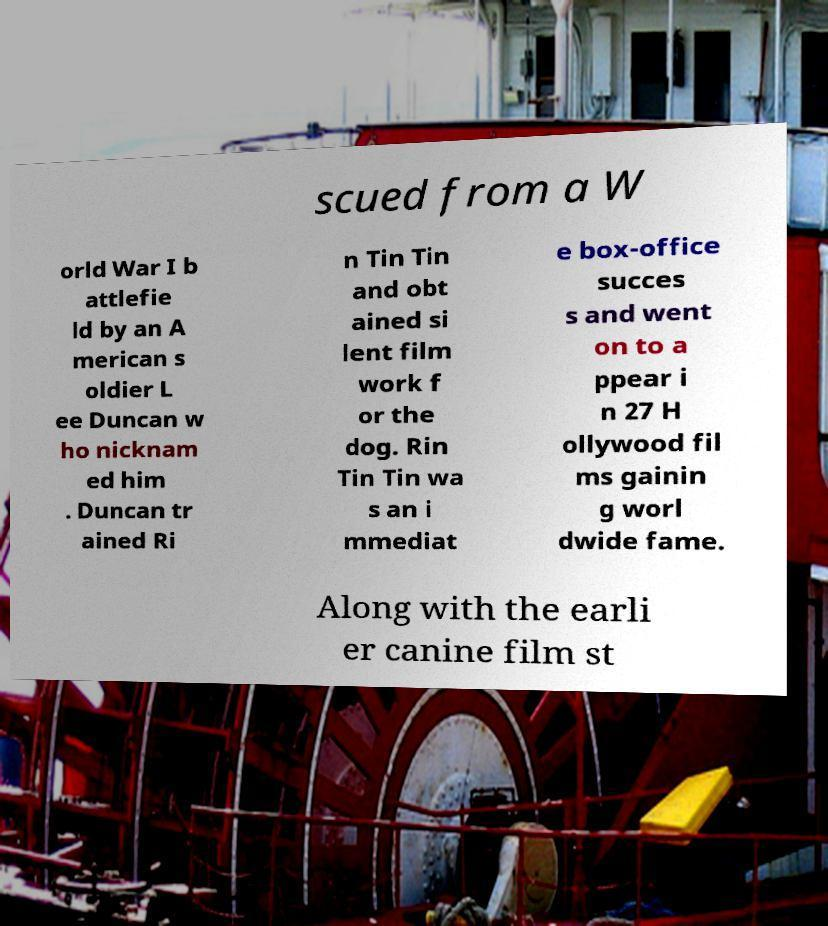For documentation purposes, I need the text within this image transcribed. Could you provide that? scued from a W orld War I b attlefie ld by an A merican s oldier L ee Duncan w ho nicknam ed him . Duncan tr ained Ri n Tin Tin and obt ained si lent film work f or the dog. Rin Tin Tin wa s an i mmediat e box-office succes s and went on to a ppear i n 27 H ollywood fil ms gainin g worl dwide fame. Along with the earli er canine film st 